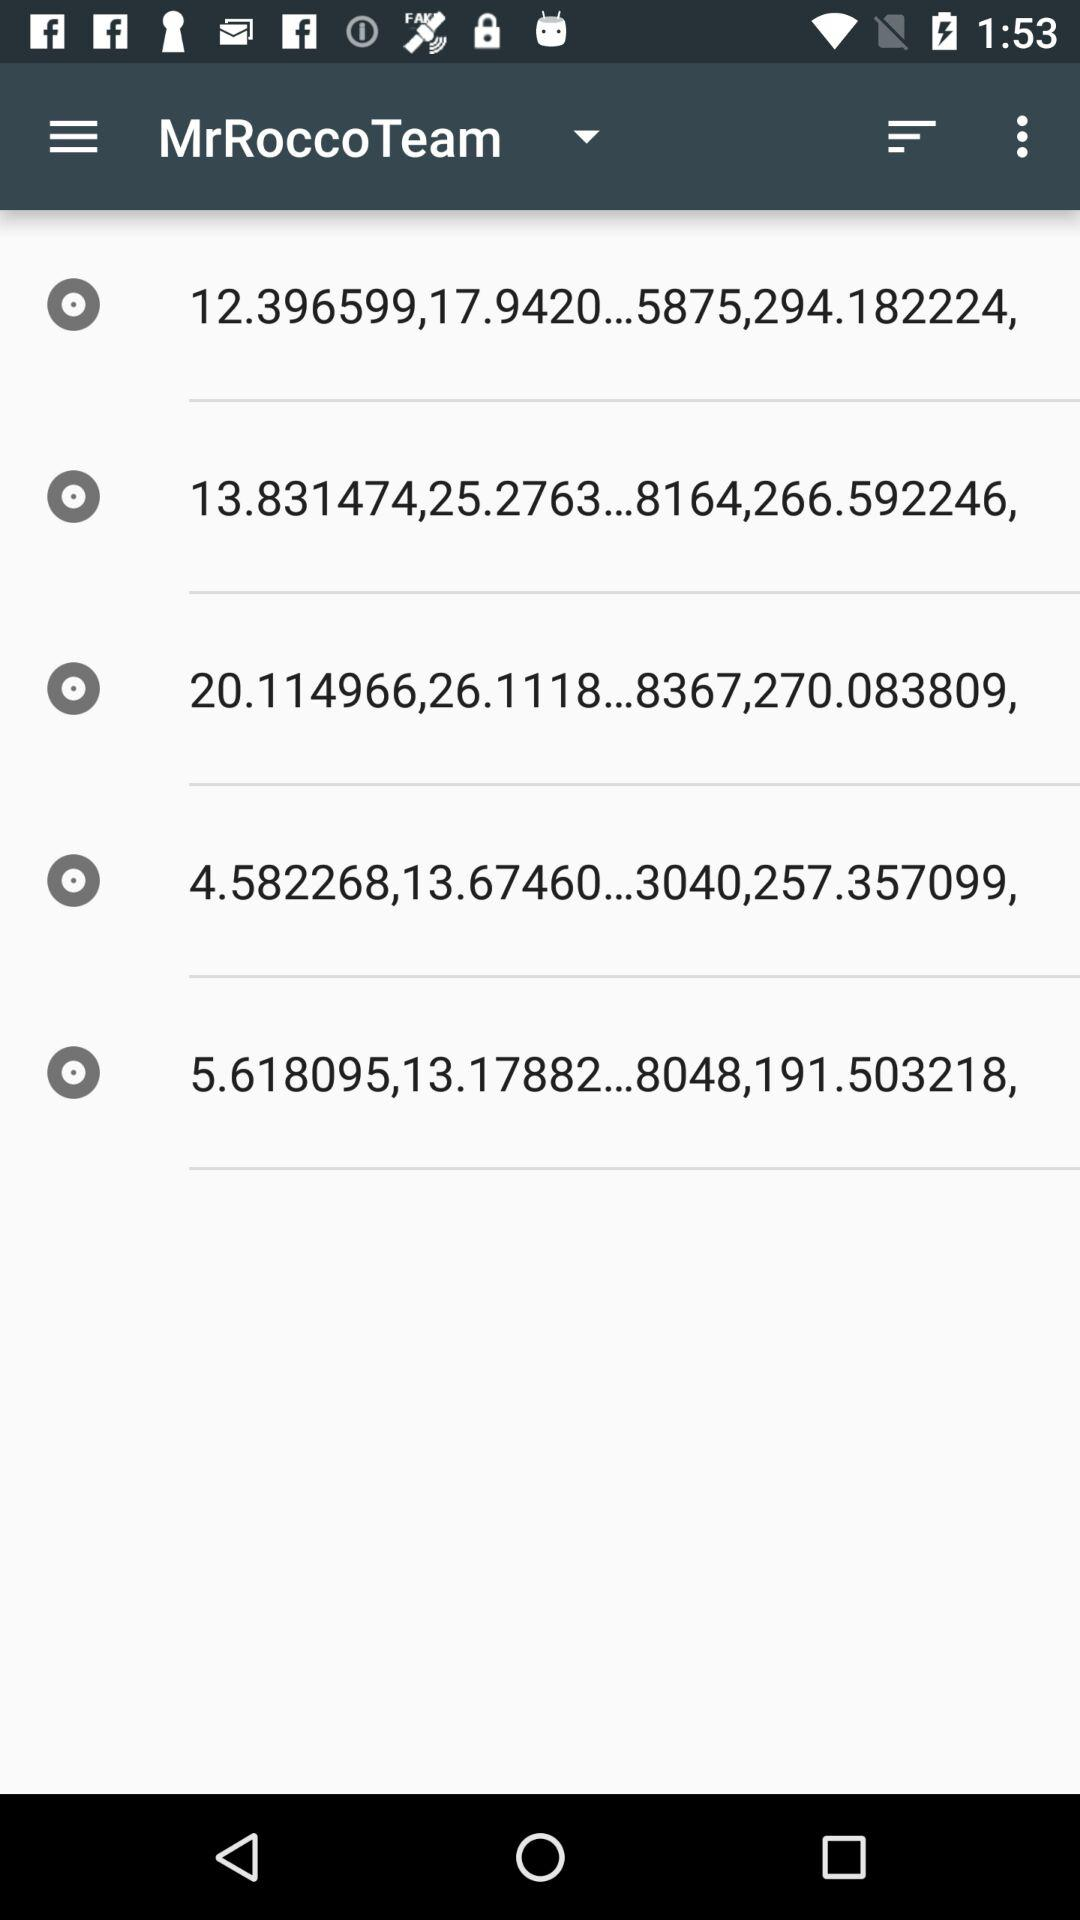Which item has the largest value in the "Value" column?
Answer the question using a single word or phrase. 8367 